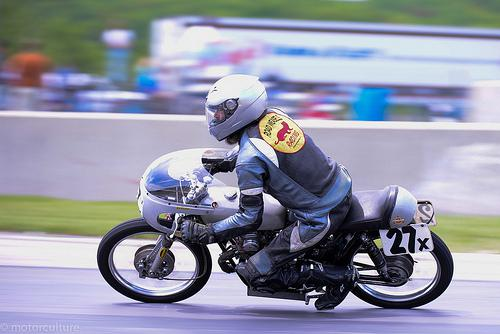Question: how is the motorcycle facing?
Choices:
A. Toward the rider.
B. Toward the horizon.
C. Towards the left side of the picture.
D. Toward the car in front.
Answer with the letter. Answer: C Question: why is the rider and motorcycle leaning?
Choices:
A. To avoid an accident.
B. To pass a car.
C. They are turning left.
D. To get into another lane.
Answer with the letter. Answer: C Question: what color is the helmet?
Choices:
A. Yellow.
B. Red.
C. Black.
D. Grey.
Answer with the letter. Answer: D Question: what is the person riding?
Choices:
A. A bicycle.
B. A motorcycle.
C. A horse.
D. An truck.
Answer with the letter. Answer: B 